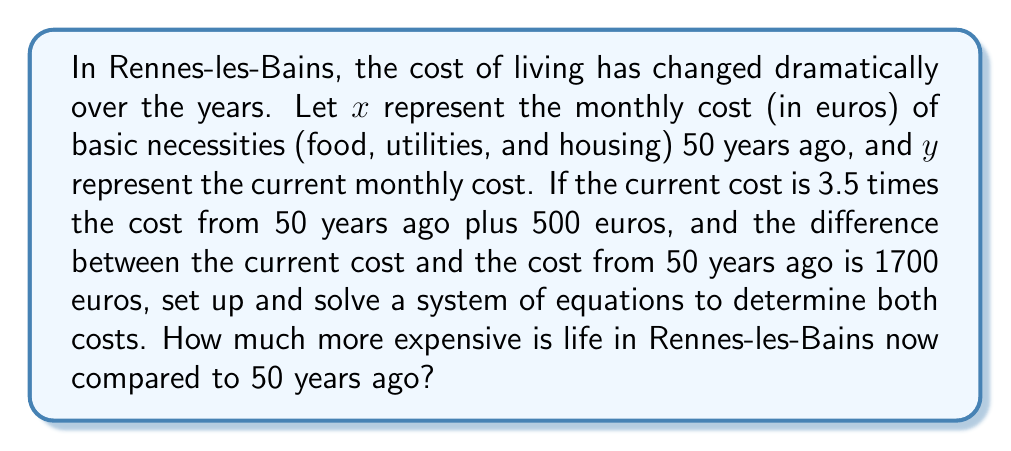Teach me how to tackle this problem. Let's approach this step-by-step:

1) First, let's set up our system of equations based on the given information:

   Equation 1: $y = 3.5x + 500$ (current cost is 3.5 times the old cost plus 500)
   Equation 2: $y - x = 1700$ (difference between current and old cost is 1700)

2) Now, let's solve this system by substitution. We'll substitute the expression for $y$ from Equation 1 into Equation 2:

   $(3.5x + 500) - x = 1700$

3) Simplify the left side of the equation:

   $2.5x + 500 = 1700$

4) Subtract 500 from both sides:

   $2.5x = 1200$

5) Divide both sides by 2.5:

   $x = 480$

6) Now that we know $x$, we can find $y$ by plugging this value into either of our original equations. Let's use Equation 1:

   $y = 3.5(480) + 500 = 1680 + 500 = 2180$

7) To find how much more expensive life is now, we subtract the old cost from the new cost:

   $2180 - 480 = 1700$

This matches our second original equation, confirming our solution is correct.
Answer: Life in Rennes-les-Bains is €1700 more expensive per month now compared to 50 years ago. 